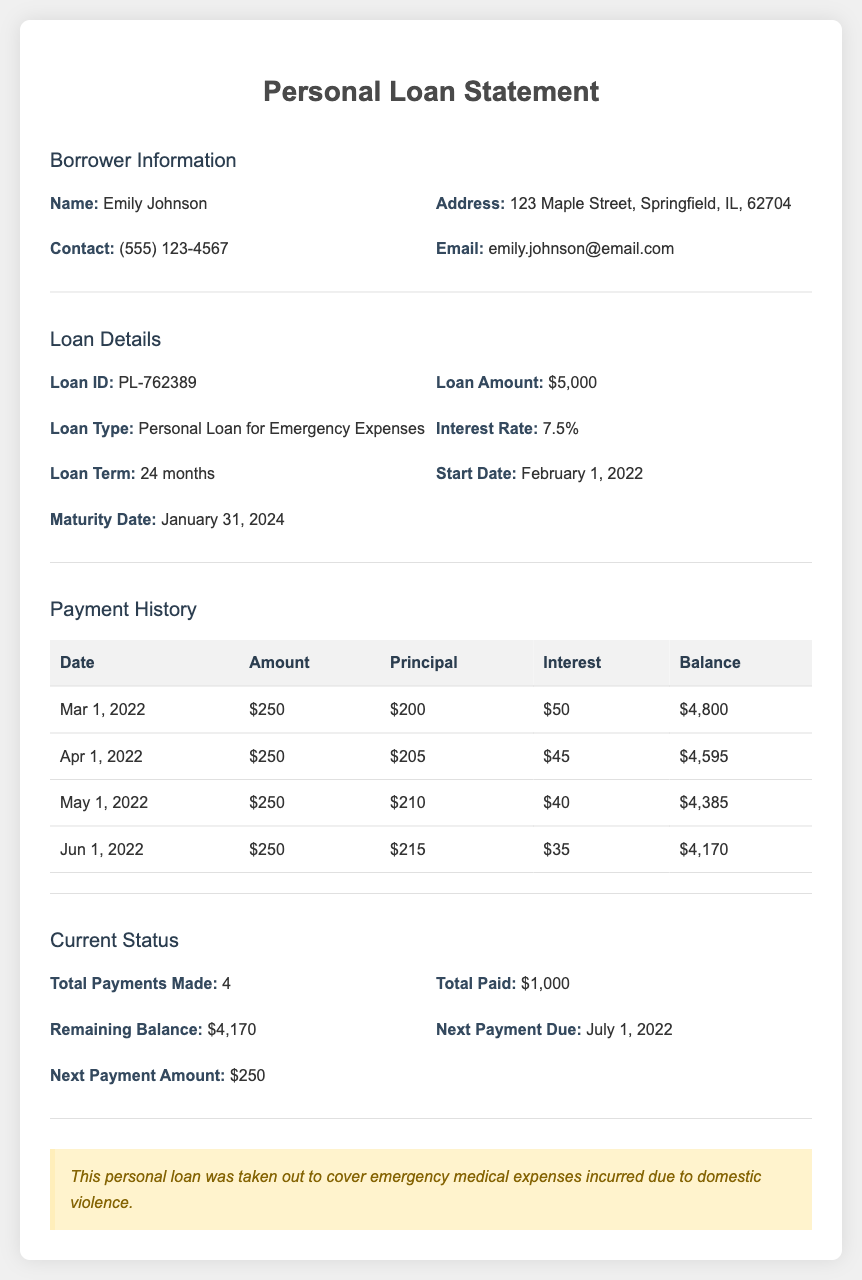What is the borrower's name? The borrower's name is listed in the document under Borrower Information.
Answer: Emily Johnson What is the loan amount? The loan amount is specified under Loan Details in the document.
Answer: $5,000 What is the interest rate on the loan? The interest rate is mentioned under Loan Details in the document.
Answer: 7.5% When is the next payment due? The next payment due date is provided in the Current Status section of the document.
Answer: July 1, 2022 How many total payments have been made? The total number of payments made is shown in the Current Status section.
Answer: 4 What is the remaining balance? The remaining balance is explicitly listed in the Current Status section.
Answer: $4,170 What were the principal and interest amounts for the first payment? The principal and interest amounts for the first payment are found in the Payment History table.
Answer: $200 and $50 What was the purpose of the loan? The document notes the purpose of the loan in a specific section.
Answer: Emergency medical expenses What is the maturity date of the loan? The maturity date is included in the Loan Details section of the document.
Answer: January 31, 2024 